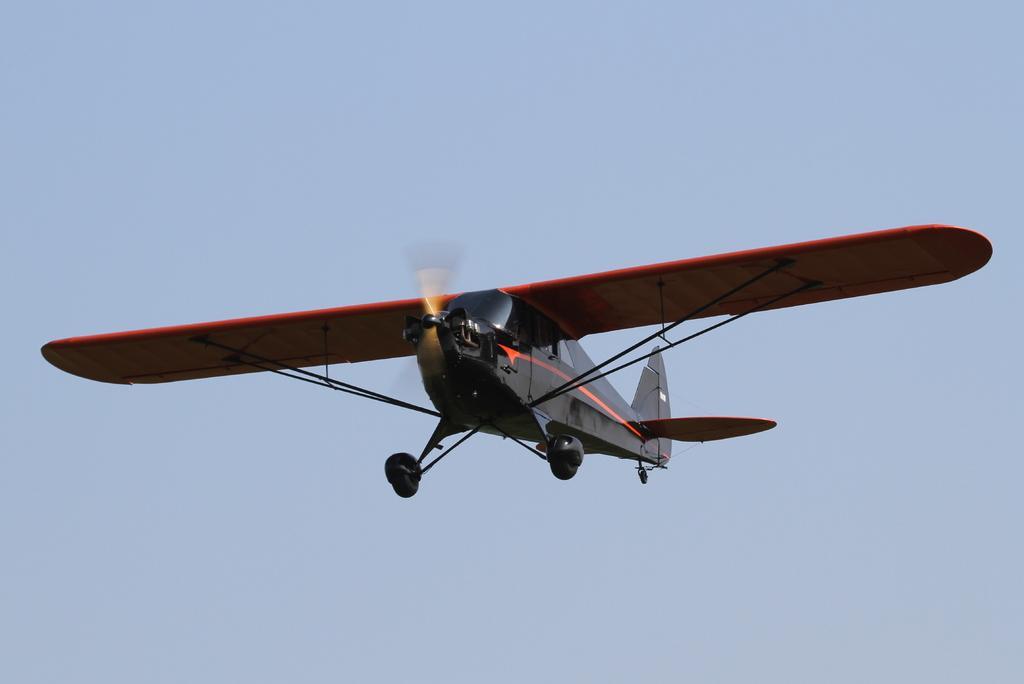Describe this image in one or two sentences. This image is taken outdoors. In the background there is a sky. In the middle of the image an airplane is flying in the sky. 